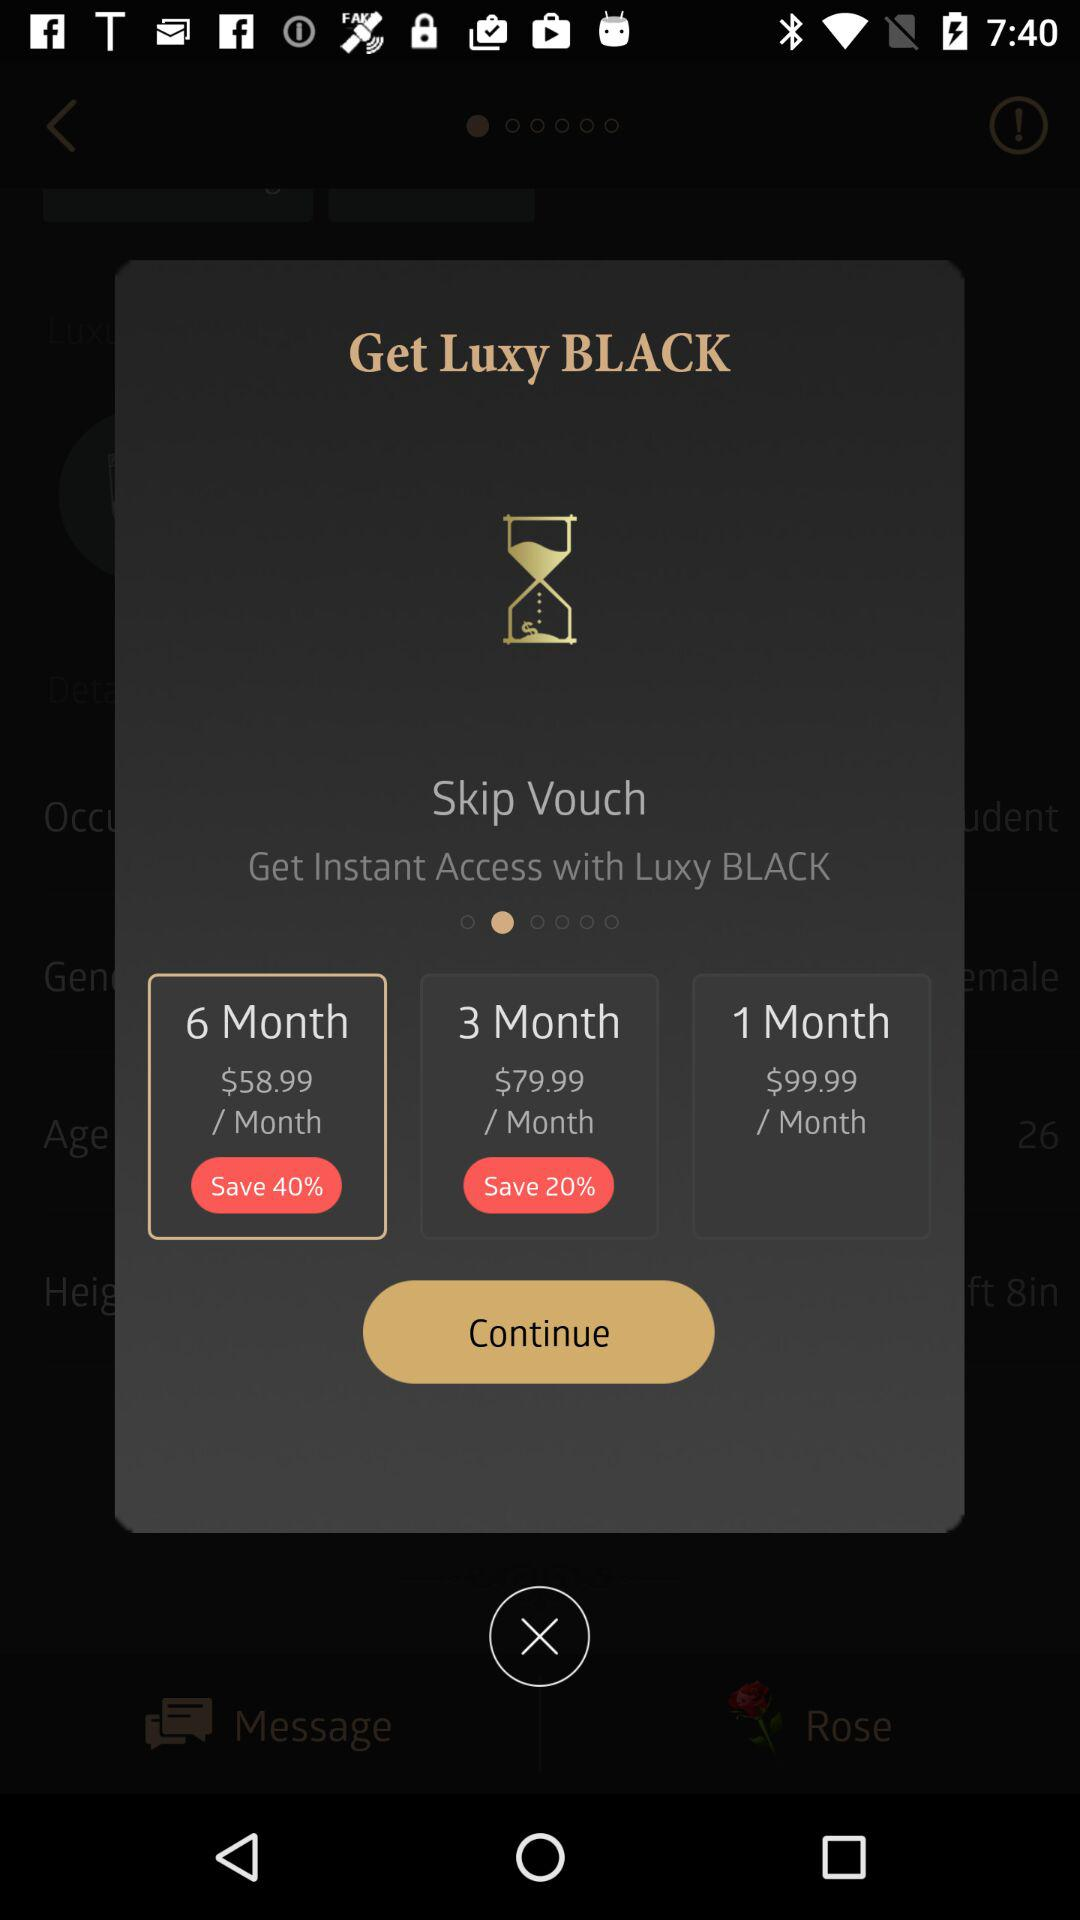How much discount is there on a 3-month subscription? There is a discount of 20% on a 3-month subscription. 